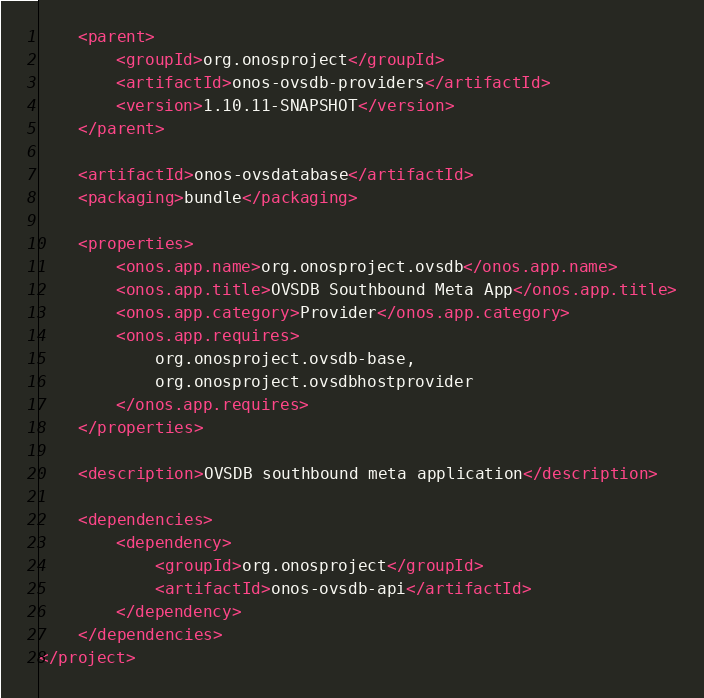<code> <loc_0><loc_0><loc_500><loc_500><_XML_>    <parent>
        <groupId>org.onosproject</groupId>
        <artifactId>onos-ovsdb-providers</artifactId>
        <version>1.10.11-SNAPSHOT</version>
    </parent>

    <artifactId>onos-ovsdatabase</artifactId>
    <packaging>bundle</packaging>

    <properties>
        <onos.app.name>org.onosproject.ovsdb</onos.app.name>
        <onos.app.title>OVSDB Southbound Meta App</onos.app.title>
        <onos.app.category>Provider</onos.app.category>
        <onos.app.requires>
            org.onosproject.ovsdb-base,
            org.onosproject.ovsdbhostprovider
        </onos.app.requires>
    </properties>

    <description>OVSDB southbound meta application</description>

    <dependencies>
        <dependency>
            <groupId>org.onosproject</groupId>
            <artifactId>onos-ovsdb-api</artifactId>
        </dependency>
    </dependencies>
</project>
</code> 